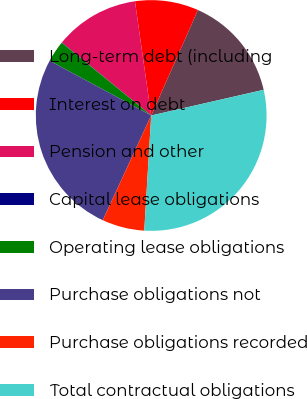<chart> <loc_0><loc_0><loc_500><loc_500><pie_chart><fcel>Long-term debt (including<fcel>Interest on debt<fcel>Pension and other<fcel>Capital lease obligations<fcel>Operating lease obligations<fcel>Purchase obligations not<fcel>Purchase obligations recorded<fcel>Total contractual obligations<nl><fcel>14.79%<fcel>8.89%<fcel>11.84%<fcel>0.05%<fcel>2.99%<fcel>25.98%<fcel>5.94%<fcel>29.53%<nl></chart> 